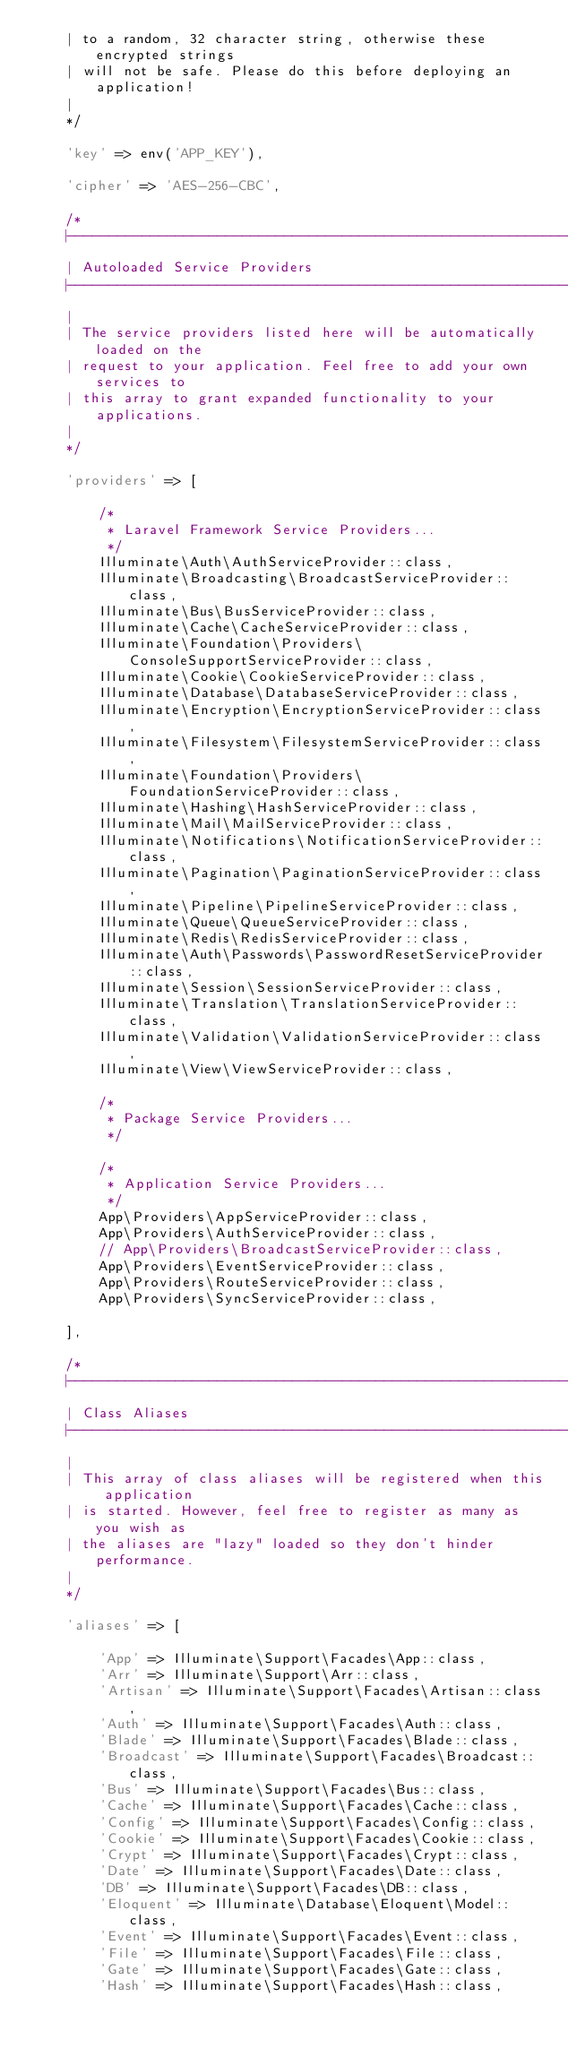Convert code to text. <code><loc_0><loc_0><loc_500><loc_500><_PHP_>    | to a random, 32 character string, otherwise these encrypted strings
    | will not be safe. Please do this before deploying an application!
    |
    */

    'key' => env('APP_KEY'),

    'cipher' => 'AES-256-CBC',

    /*
    |--------------------------------------------------------------------------
    | Autoloaded Service Providers
    |--------------------------------------------------------------------------
    |
    | The service providers listed here will be automatically loaded on the
    | request to your application. Feel free to add your own services to
    | this array to grant expanded functionality to your applications.
    |
    */

    'providers' => [

        /*
         * Laravel Framework Service Providers...
         */
        Illuminate\Auth\AuthServiceProvider::class,
        Illuminate\Broadcasting\BroadcastServiceProvider::class,
        Illuminate\Bus\BusServiceProvider::class,
        Illuminate\Cache\CacheServiceProvider::class,
        Illuminate\Foundation\Providers\ConsoleSupportServiceProvider::class,
        Illuminate\Cookie\CookieServiceProvider::class,
        Illuminate\Database\DatabaseServiceProvider::class,
        Illuminate\Encryption\EncryptionServiceProvider::class,
        Illuminate\Filesystem\FilesystemServiceProvider::class,
        Illuminate\Foundation\Providers\FoundationServiceProvider::class,
        Illuminate\Hashing\HashServiceProvider::class,
        Illuminate\Mail\MailServiceProvider::class,
        Illuminate\Notifications\NotificationServiceProvider::class,
        Illuminate\Pagination\PaginationServiceProvider::class,
        Illuminate\Pipeline\PipelineServiceProvider::class,
        Illuminate\Queue\QueueServiceProvider::class,
        Illuminate\Redis\RedisServiceProvider::class,
        Illuminate\Auth\Passwords\PasswordResetServiceProvider::class,
        Illuminate\Session\SessionServiceProvider::class,
        Illuminate\Translation\TranslationServiceProvider::class,
        Illuminate\Validation\ValidationServiceProvider::class,
        Illuminate\View\ViewServiceProvider::class,

        /*
         * Package Service Providers...
         */

        /*
         * Application Service Providers...
         */
        App\Providers\AppServiceProvider::class,
        App\Providers\AuthServiceProvider::class,
        // App\Providers\BroadcastServiceProvider::class,
        App\Providers\EventServiceProvider::class,
        App\Providers\RouteServiceProvider::class,
        App\Providers\SyncServiceProvider::class,

    ],

    /*
    |--------------------------------------------------------------------------
    | Class Aliases
    |--------------------------------------------------------------------------
    |
    | This array of class aliases will be registered when this application
    | is started. However, feel free to register as many as you wish as
    | the aliases are "lazy" loaded so they don't hinder performance.
    |
    */

    'aliases' => [

        'App' => Illuminate\Support\Facades\App::class,
        'Arr' => Illuminate\Support\Arr::class,
        'Artisan' => Illuminate\Support\Facades\Artisan::class,
        'Auth' => Illuminate\Support\Facades\Auth::class,
        'Blade' => Illuminate\Support\Facades\Blade::class,
        'Broadcast' => Illuminate\Support\Facades\Broadcast::class,
        'Bus' => Illuminate\Support\Facades\Bus::class,
        'Cache' => Illuminate\Support\Facades\Cache::class,
        'Config' => Illuminate\Support\Facades\Config::class,
        'Cookie' => Illuminate\Support\Facades\Cookie::class,
        'Crypt' => Illuminate\Support\Facades\Crypt::class,
        'Date' => Illuminate\Support\Facades\Date::class,
        'DB' => Illuminate\Support\Facades\DB::class,
        'Eloquent' => Illuminate\Database\Eloquent\Model::class,
        'Event' => Illuminate\Support\Facades\Event::class,
        'File' => Illuminate\Support\Facades\File::class,
        'Gate' => Illuminate\Support\Facades\Gate::class,
        'Hash' => Illuminate\Support\Facades\Hash::class,</code> 